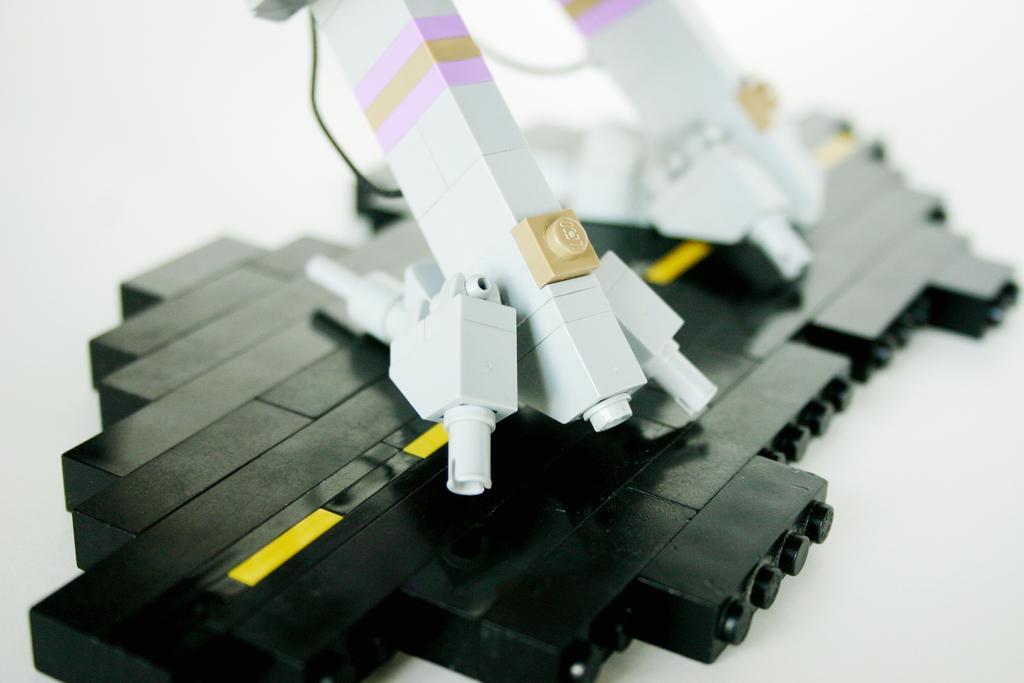Describe this image in one or two sentences. In this image I can see few black and few white color things. I can also see this image is little bit blurry from background. 